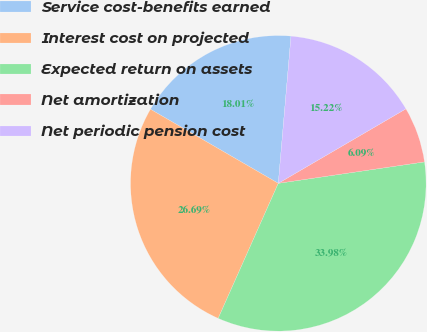<chart> <loc_0><loc_0><loc_500><loc_500><pie_chart><fcel>Service cost-benefits earned<fcel>Interest cost on projected<fcel>Expected return on assets<fcel>Net amortization<fcel>Net periodic pension cost<nl><fcel>18.01%<fcel>26.69%<fcel>33.98%<fcel>6.09%<fcel>15.22%<nl></chart> 